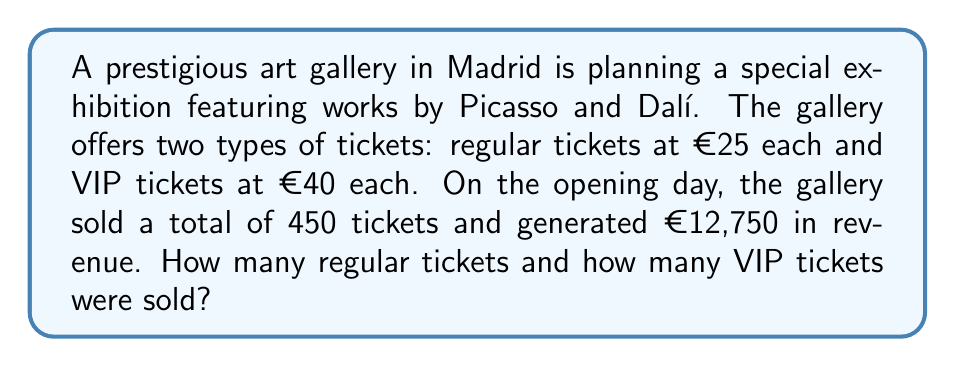What is the answer to this math problem? Let's approach this problem using a system of equations. We'll define our variables as:

$x$ = number of regular tickets sold
$y$ = number of VIP tickets sold

From the information given, we can create two equations:

1. Total number of tickets sold:
   $x + y = 450$

2. Total revenue generated:
   $25x + 40y = 12750$

Now we have a system of two equations with two unknowns:

$$\begin{cases}
x + y = 450 \\
25x + 40y = 12750
\end{cases}$$

To solve this system, let's use the substitution method:

1. From the first equation, express $x$ in terms of $y$:
   $x = 450 - y$

2. Substitute this expression into the second equation:
   $25(450 - y) + 40y = 12750$

3. Simplify:
   $11250 - 25y + 40y = 12750$
   $11250 + 15y = 12750$

4. Solve for $y$:
   $15y = 1500$
   $y = 100$

5. Substitute $y = 100$ back into the equation from step 1 to find $x$:
   $x = 450 - 100 = 350$

Therefore, the gallery sold 350 regular tickets and 100 VIP tickets.

To verify:
- Total tickets: $350 + 100 = 450$ ✓
- Total revenue: $(350 × €25) + (100 × €40) = €8750 + €4000 = €12750$ ✓
Answer: The gallery sold 350 regular tickets and 100 VIP tickets. 